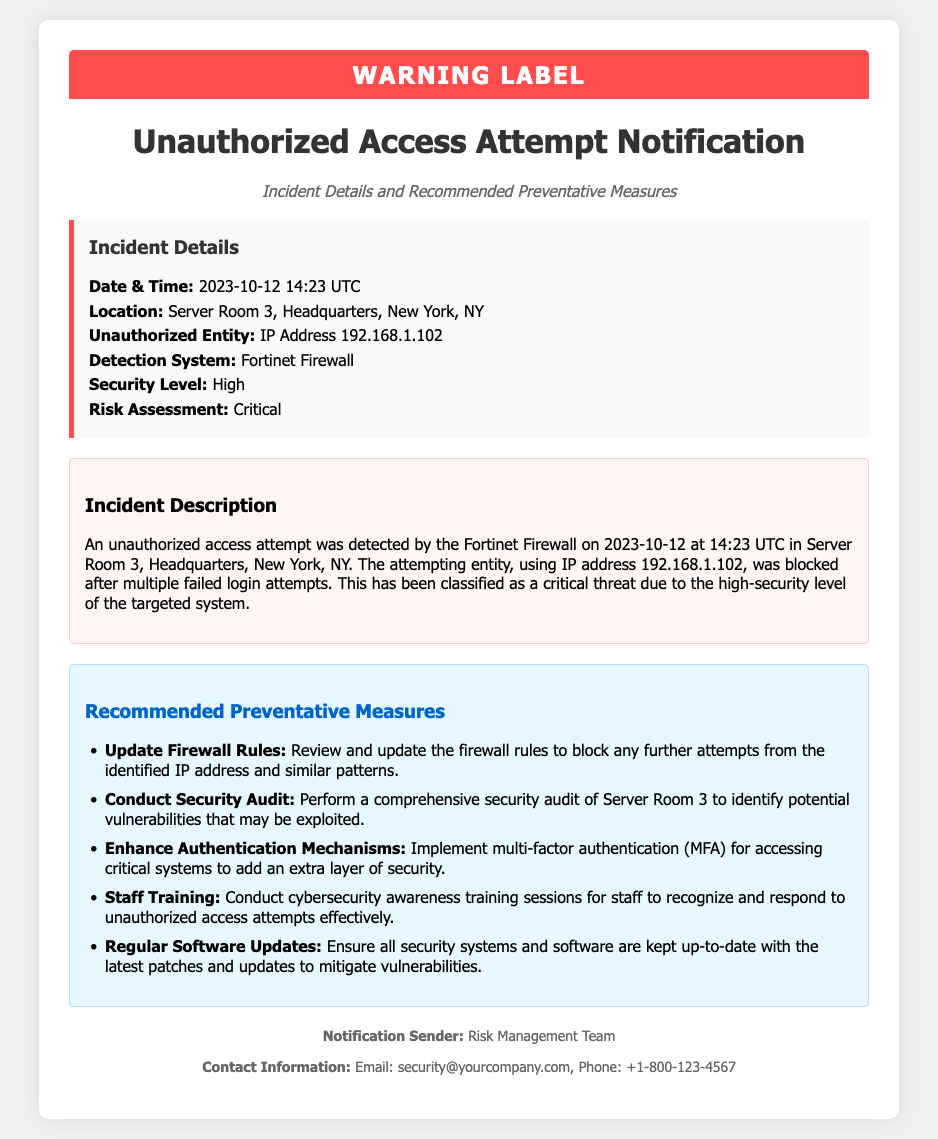What is the date and time of the incident? The date and time of the incident is mentioned as 2023-10-12 14:23 UTC in the incident details section.
Answer: 2023-10-12 14:23 UTC What is the location of the unauthorized access attempt? The document specifies the location as Server Room 3, Headquarters, New York, NY.
Answer: Server Room 3, Headquarters, New York, NY What is the IP address of the unauthorized entity? The IP address of the unauthorized entity is listed as 192.168.1.102.
Answer: 192.168.1.102 What type of system detected the unauthorized access attempt? The detection system mentioned in the document is the Fortinet Firewall.
Answer: Fortinet Firewall What security level is associated with this incident? The document states that the security level is classified as High.
Answer: High What is the risk assessment for the incident? The risk assessment is marked as Critical.
Answer: Critical Which preventative measure involves staff actions? The document recommends conducting cybersecurity awareness training sessions for staff.
Answer: Staff Training What should be updated to prevent future attempts from the identified IP address? The document advises to review and update the firewall rules.
Answer: Update Firewall Rules How can access to critical systems be enhanced? The recommended measure is to implement multi-factor authentication (MFA).
Answer: Multi-factor authentication (MFA) 